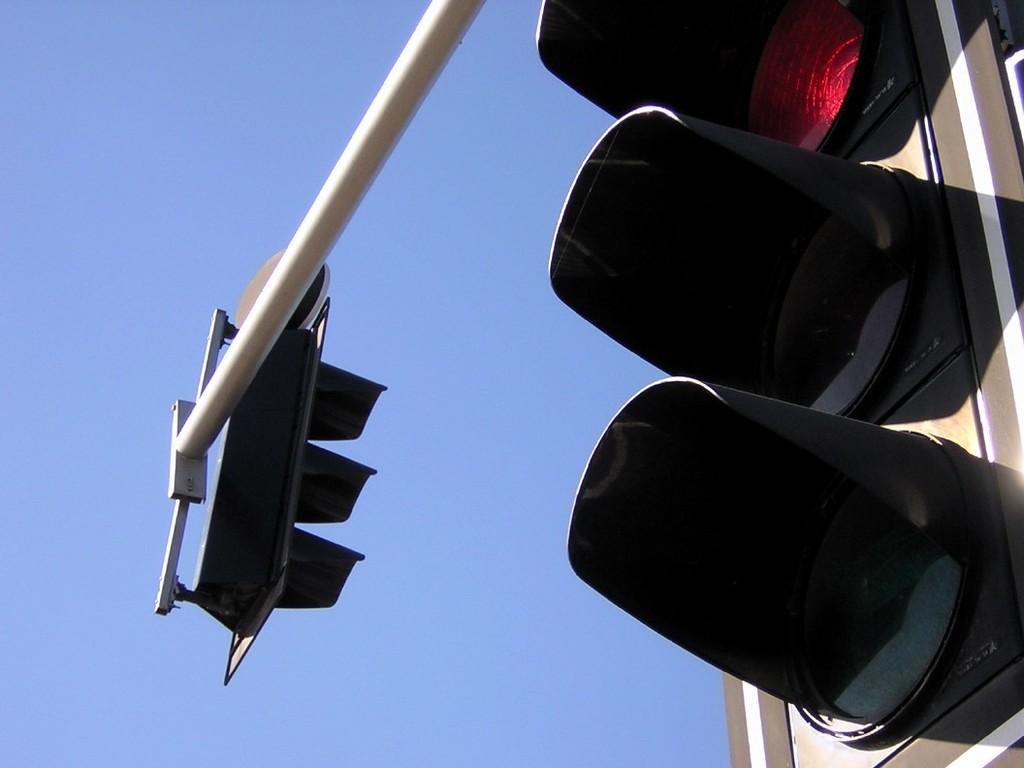What is the main object in the image? There is a traffic signal in the image. What is supporting the traffic signal? There is a pole in the image that supports the traffic signal. What can be seen in the sky in the image? The sky is clear in the image. Can you see a lake in the image? No, there is no lake present in the image. Is there a pig visible in the image? No, there is no pig present in the image. 